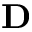Convert formula to latex. <formula><loc_0><loc_0><loc_500><loc_500>D</formula> 